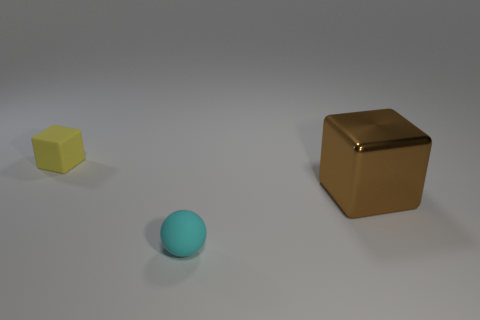Add 2 big yellow cubes. How many objects exist? 5 Subtract all cubes. How many objects are left? 1 Subtract 0 gray balls. How many objects are left? 3 Subtract all big purple objects. Subtract all small objects. How many objects are left? 1 Add 2 metallic cubes. How many metallic cubes are left? 3 Add 3 shiny cubes. How many shiny cubes exist? 4 